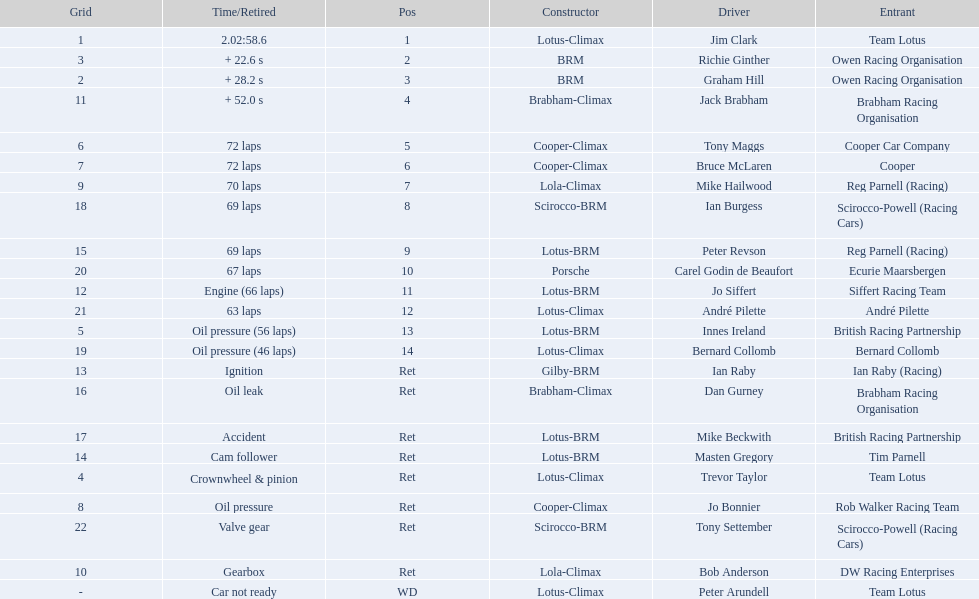Who were the drivers in the the 1963 international gold cup? Jim Clark, Richie Ginther, Graham Hill, Jack Brabham, Tony Maggs, Bruce McLaren, Mike Hailwood, Ian Burgess, Peter Revson, Carel Godin de Beaufort, Jo Siffert, André Pilette, Innes Ireland, Bernard Collomb, Ian Raby, Dan Gurney, Mike Beckwith, Masten Gregory, Trevor Taylor, Jo Bonnier, Tony Settember, Bob Anderson, Peter Arundell. Which drivers drove a cooper-climax car? Tony Maggs, Bruce McLaren, Jo Bonnier. What did these drivers place? 5, 6, Ret. What was the best placing position? 5. Who was the driver with this placing? Tony Maggs. 